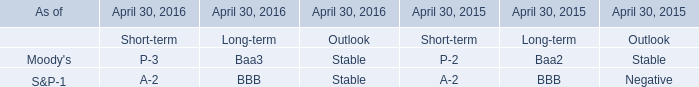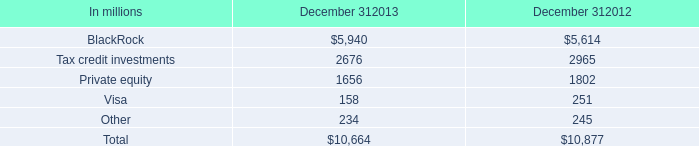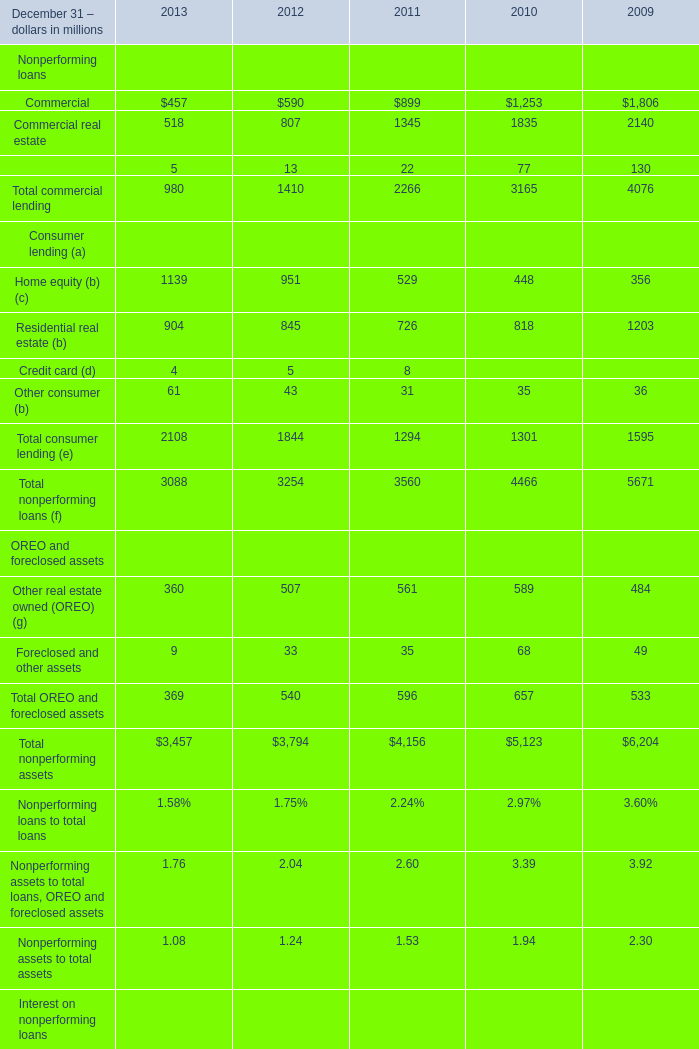in these equity investment balances , what is the percent of unfunded commitments at december 31 , 2013? 
Computations: (802 / 10664)
Answer: 0.07521. 